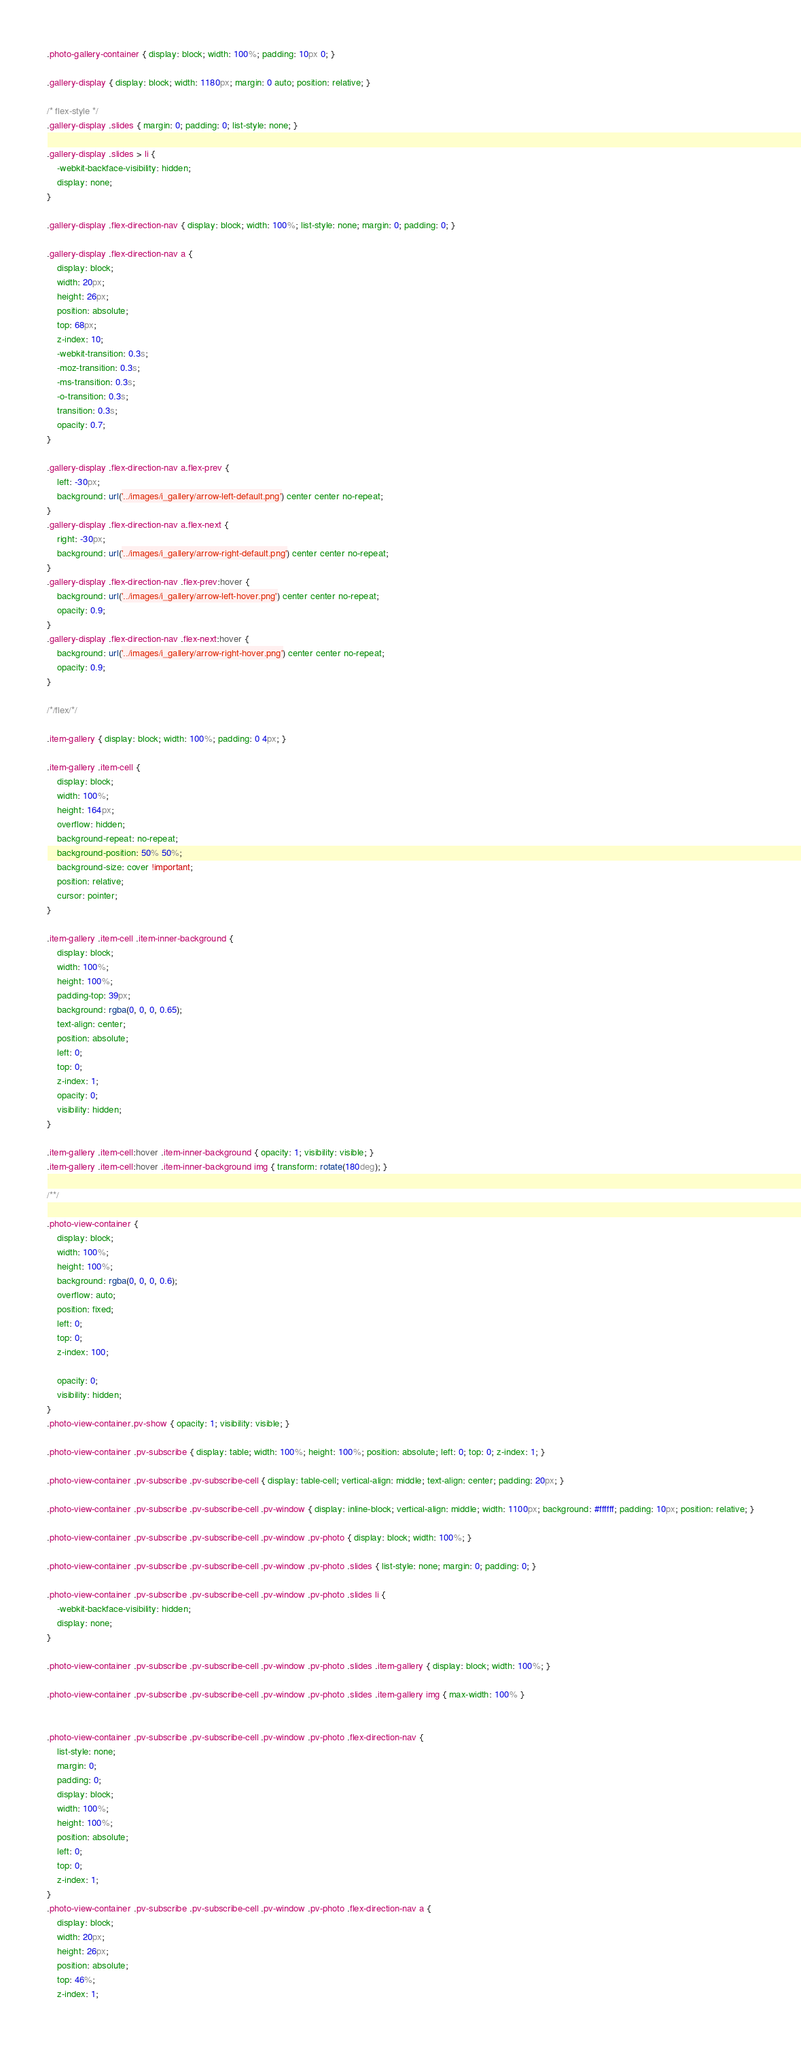Convert code to text. <code><loc_0><loc_0><loc_500><loc_500><_CSS_>
.photo-gallery-container { display: block; width: 100%; padding: 10px 0; }

.gallery-display { display: block; width: 1180px; margin: 0 auto; position: relative; }

/* flex-style */
.gallery-display .slides { margin: 0; padding: 0; list-style: none; }

.gallery-display .slides > li {
    -webkit-backface-visibility: hidden;
    display: none;
}

.gallery-display .flex-direction-nav { display: block; width: 100%; list-style: none; margin: 0; padding: 0; }

.gallery-display .flex-direction-nav a {
    display: block;
    width: 20px;
    height: 26px;
    position: absolute;
    top: 68px;
    z-index: 10;
    -webkit-transition: 0.3s;
    -moz-transition: 0.3s;
    -ms-transition: 0.3s;
    -o-transition: 0.3s;
    transition: 0.3s;
    opacity: 0.7;
}

.gallery-display .flex-direction-nav a.flex-prev {
    left: -30px;
    background: url('../images/i_gallery/arrow-left-default.png') center center no-repeat;
}
.gallery-display .flex-direction-nav a.flex-next {
    right: -30px;
    background: url('../images/i_gallery/arrow-right-default.png') center center no-repeat;
}
.gallery-display .flex-direction-nav .flex-prev:hover {
    background: url('../images/i_gallery/arrow-left-hover.png') center center no-repeat;
    opacity: 0.9;
}
.gallery-display .flex-direction-nav .flex-next:hover {
    background: url('../images/i_gallery/arrow-right-hover.png') center center no-repeat;
    opacity: 0.9;
}

/*/flex/*/

.item-gallery { display: block; width: 100%; padding: 0 4px; }

.item-gallery .item-cell {
    display: block;
    width: 100%;
    height: 164px;
    overflow: hidden;
    background-repeat: no-repeat;
    background-position: 50% 50%;
    background-size: cover !important;
    position: relative;
    cursor: pointer;
}

.item-gallery .item-cell .item-inner-background {
    display: block;
    width: 100%;
    height: 100%;
    padding-top: 39px;
    background: rgba(0, 0, 0, 0.65);
    text-align: center;
    position: absolute;
    left: 0;
    top: 0;
    z-index: 1;
    opacity: 0;
    visibility: hidden;
}

.item-gallery .item-cell:hover .item-inner-background { opacity: 1; visibility: visible; }
.item-gallery .item-cell:hover .item-inner-background img { transform: rotate(180deg); }

/**/

.photo-view-container {
    display: block;
    width: 100%;
    height: 100%;
    background: rgba(0, 0, 0, 0.6);
    overflow: auto;
    position: fixed;
    left: 0;
    top: 0;
    z-index: 100;

    opacity: 0;
    visibility: hidden;
}
.photo-view-container.pv-show { opacity: 1; visibility: visible; }

.photo-view-container .pv-subscribe { display: table; width: 100%; height: 100%; position: absolute; left: 0; top: 0; z-index: 1; }

.photo-view-container .pv-subscribe .pv-subscribe-cell { display: table-cell; vertical-align: middle; text-align: center; padding: 20px; }

.photo-view-container .pv-subscribe .pv-subscribe-cell .pv-window { display: inline-block; vertical-align: middle; width: 1100px; background: #ffffff; padding: 10px; position: relative; }

.photo-view-container .pv-subscribe .pv-subscribe-cell .pv-window .pv-photo { display: block; width: 100%; }

.photo-view-container .pv-subscribe .pv-subscribe-cell .pv-window .pv-photo .slides { list-style: none; margin: 0; padding: 0; }

.photo-view-container .pv-subscribe .pv-subscribe-cell .pv-window .pv-photo .slides li {
    -webkit-backface-visibility: hidden;
    display: none;
}

.photo-view-container .pv-subscribe .pv-subscribe-cell .pv-window .pv-photo .slides .item-gallery { display: block; width: 100%; }

.photo-view-container .pv-subscribe .pv-subscribe-cell .pv-window .pv-photo .slides .item-gallery img { max-width: 100% }


.photo-view-container .pv-subscribe .pv-subscribe-cell .pv-window .pv-photo .flex-direction-nav {
    list-style: none;
    margin: 0;
    padding: 0;
    display: block;
    width: 100%;
    height: 100%;
    position: absolute;
    left: 0;
    top: 0;
    z-index: 1;
}
.photo-view-container .pv-subscribe .pv-subscribe-cell .pv-window .pv-photo .flex-direction-nav a {
    display: block;
    width: 20px;
    height: 26px;
    position: absolute;
    top: 46%;
    z-index: 1;</code> 